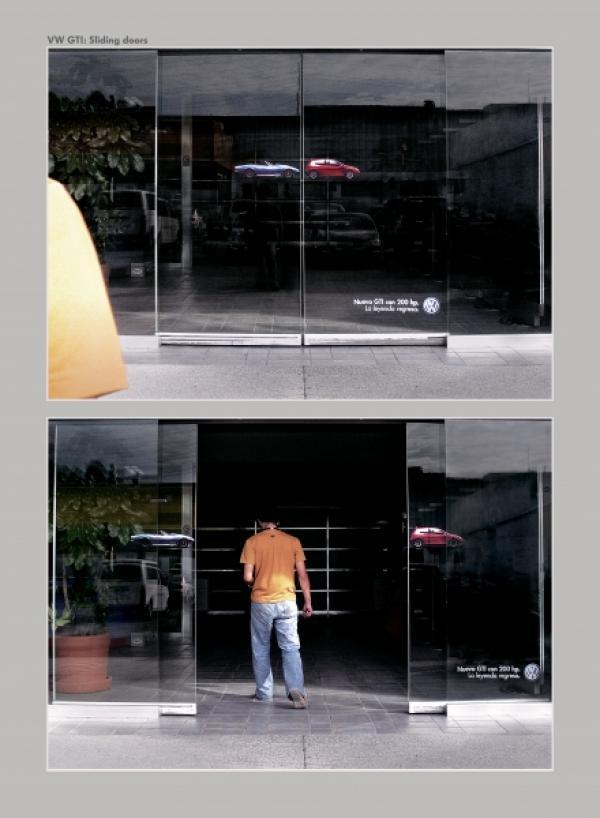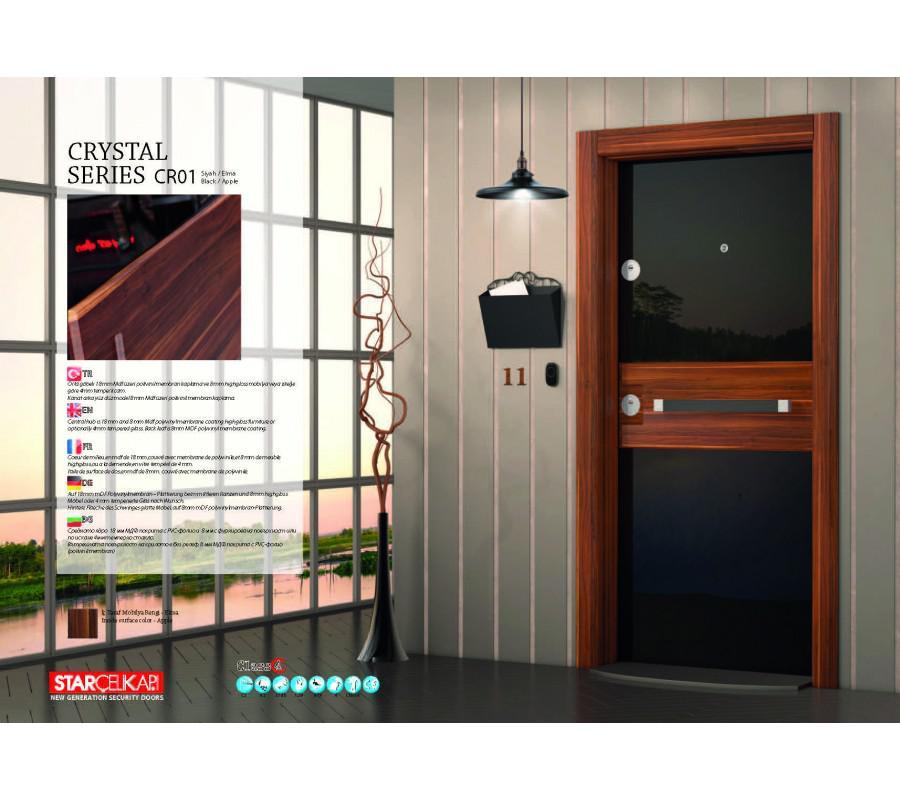The first image is the image on the left, the second image is the image on the right. Considering the images on both sides, is "One of the images is split; the same door is being shown both open, and closed." valid? Answer yes or no. Yes. 